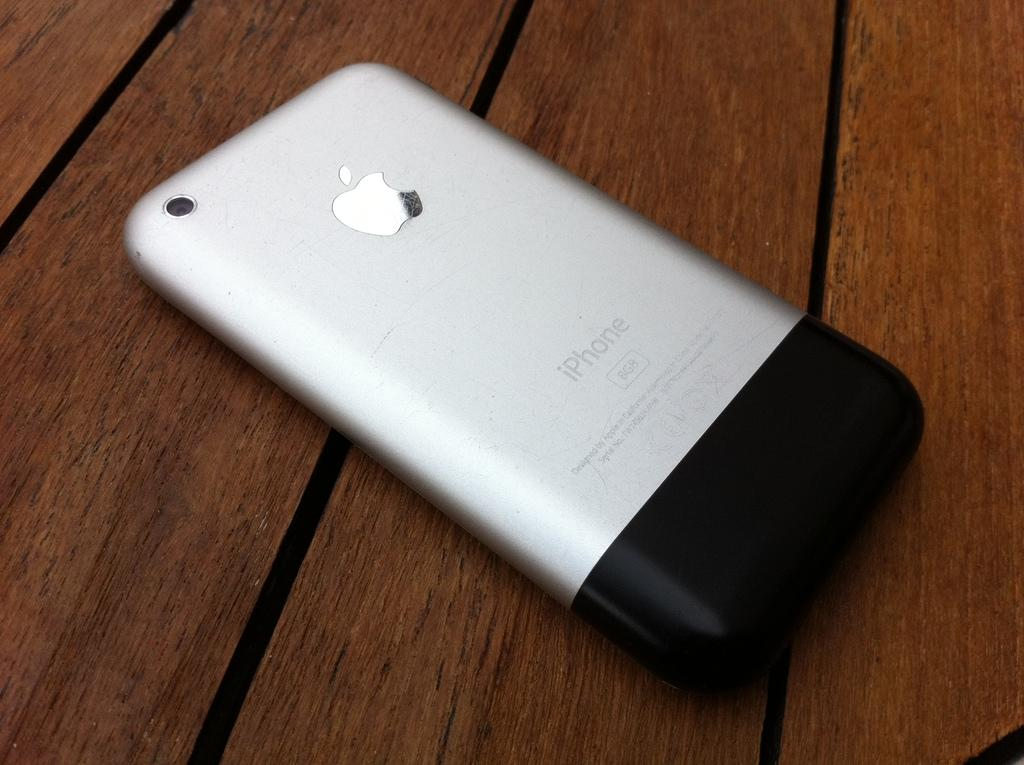<image>
Render a clear and concise summary of the photo. the back of a silver 8mb iphone on a wooden table 